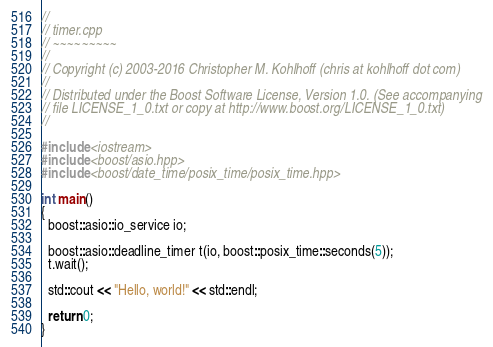Convert code to text. <code><loc_0><loc_0><loc_500><loc_500><_C++_>//
// timer.cpp
// ~~~~~~~~~
//
// Copyright (c) 2003-2016 Christopher M. Kohlhoff (chris at kohlhoff dot com)
//
// Distributed under the Boost Software License, Version 1.0. (See accompanying
// file LICENSE_1_0.txt or copy at http://www.boost.org/LICENSE_1_0.txt)
//

#include <iostream>
#include <boost/asio.hpp>
#include <boost/date_time/posix_time/posix_time.hpp>

int main()
{
  boost::asio::io_service io;

  boost::asio::deadline_timer t(io, boost::posix_time::seconds(5));
  t.wait();

  std::cout << "Hello, world!" << std::endl;

  return 0;
}
</code> 